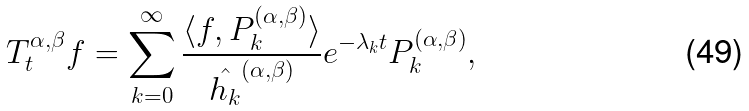<formula> <loc_0><loc_0><loc_500><loc_500>T _ { t } ^ { \alpha , \beta } f = \sum _ { k = 0 } ^ { \infty } \frac { \langle f , P _ { k } ^ { ( \alpha , \beta ) } \rangle } { \hat { h _ { k } } ^ { \left ( \alpha , \beta \right ) } } e ^ { - \lambda _ { k } t } P _ { k } ^ { ( \alpha , \beta ) } ,</formula> 